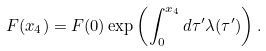<formula> <loc_0><loc_0><loc_500><loc_500>F ( x _ { 4 } ) = F ( 0 ) \exp \left ( \int _ { 0 } ^ { x _ { 4 } } d \tau ^ { \prime } \lambda ( \tau ^ { \prime } ) \right ) .</formula> 